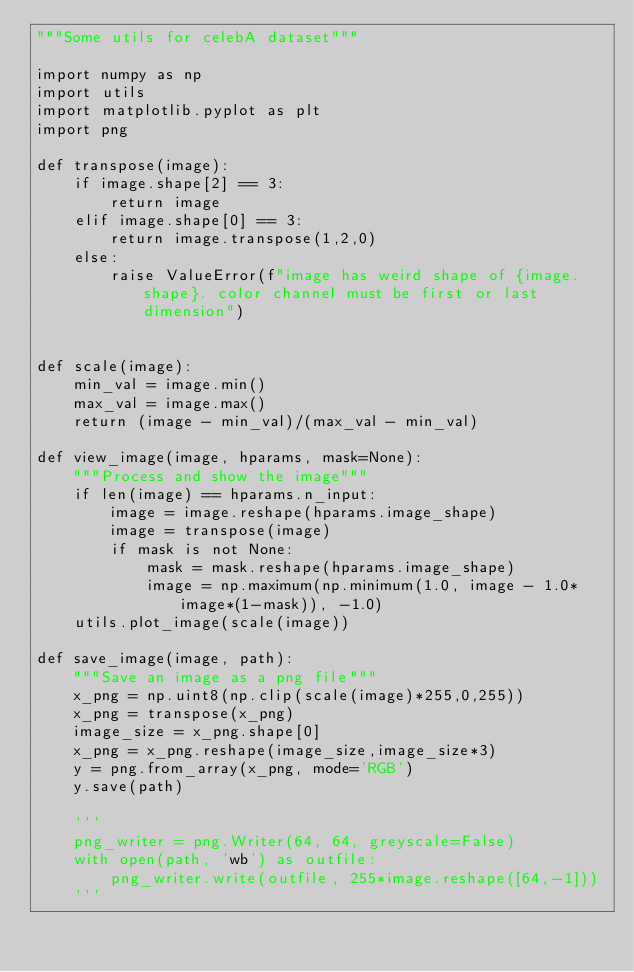<code> <loc_0><loc_0><loc_500><loc_500><_Python_>"""Some utils for celebA dataset"""

import numpy as np
import utils
import matplotlib.pyplot as plt
import png

def transpose(image):
    if image.shape[2] == 3:
        return image
    elif image.shape[0] == 3:
        return image.transpose(1,2,0)
    else:
        raise ValueError(f"image has weird shape of {image.shape}. color channel must be first or last dimension")


def scale(image):
    min_val = image.min()
    max_val = image.max()
    return (image - min_val)/(max_val - min_val)

def view_image(image, hparams, mask=None):
    """Process and show the image"""
    if len(image) == hparams.n_input:
        image = image.reshape(hparams.image_shape)
        image = transpose(image)
        if mask is not None:
            mask = mask.reshape(hparams.image_shape)
            image = np.maximum(np.minimum(1.0, image - 1.0*image*(1-mask)), -1.0)
    utils.plot_image(scale(image))

def save_image(image, path):
    """Save an image as a png file"""
    x_png = np.uint8(np.clip(scale(image)*255,0,255))
    x_png = transpose(x_png)
    image_size = x_png.shape[0]
    x_png = x_png.reshape(image_size,image_size*3)
    y = png.from_array(x_png, mode='RGB')
    y.save(path)

    '''
    png_writer = png.Writer(64, 64, greyscale=False)
    with open(path, 'wb') as outfile:
        png_writer.write(outfile, 255*image.reshape([64,-1]))
    '''
</code> 